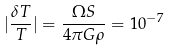<formula> <loc_0><loc_0><loc_500><loc_500>| \frac { { \delta } T } { T } | = \frac { { \Omega } S } { 4 { \pi } G { \rho } } = 1 0 ^ { - 7 }</formula> 